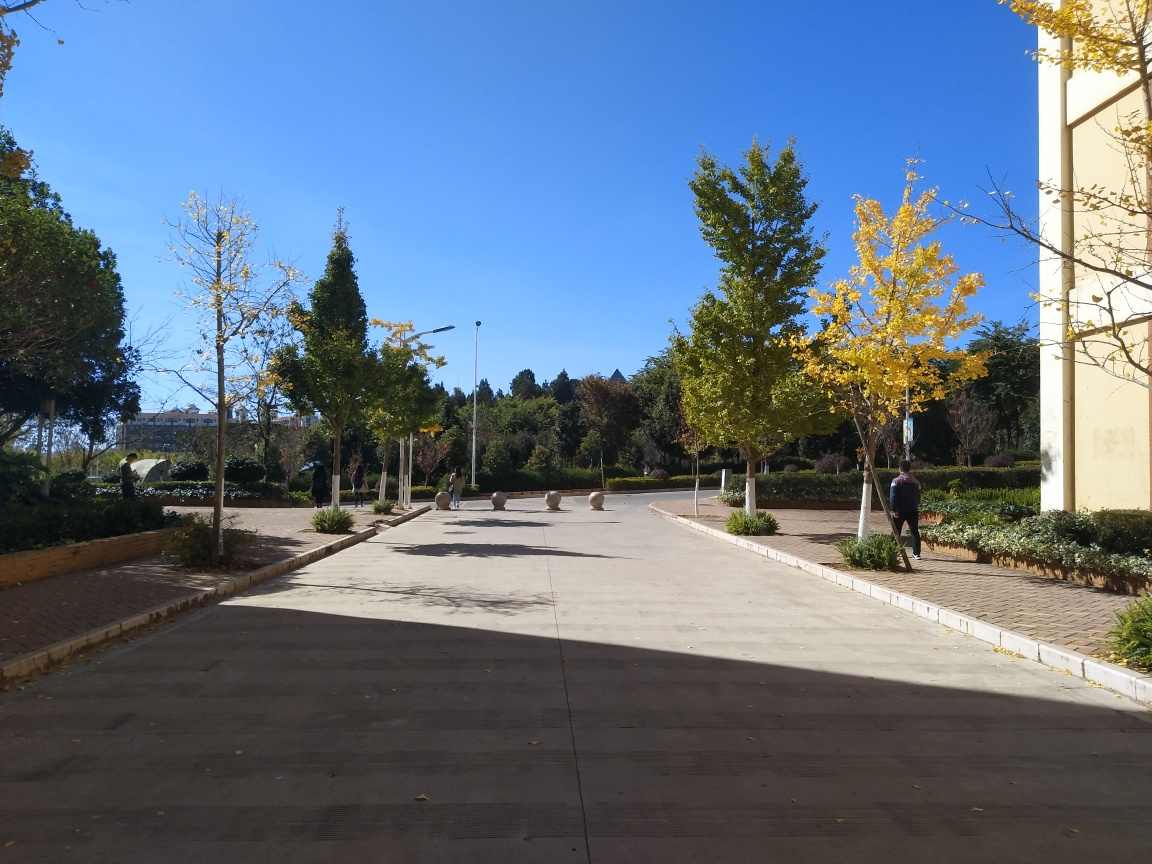What time of day does it seem to be in the image? The long shadows and the warm, soft quality of the light suggest it's either early morning or late afternoon. The position and angle of the shadows indicate the sun is relatively low in the sky. 